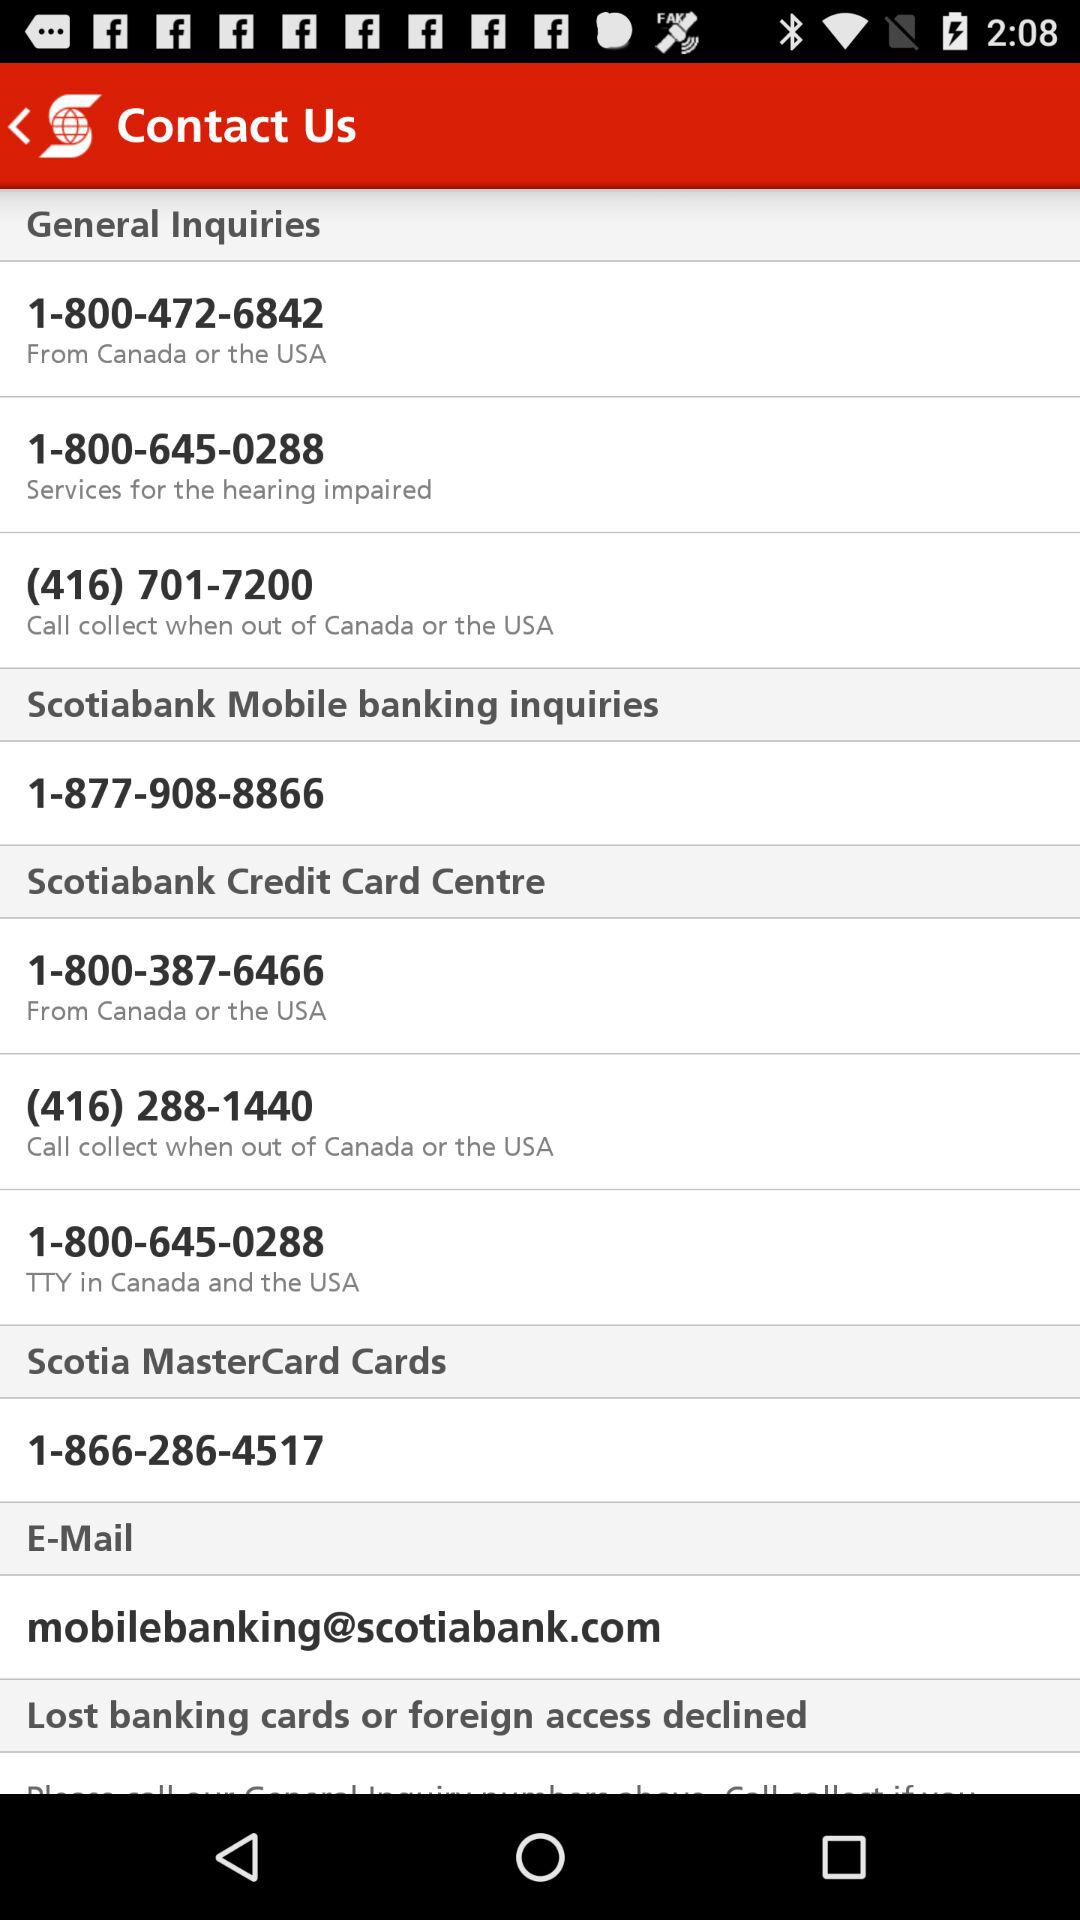What's the phone number for mobile banking inquiries? The phone number for mobile banking inquiries is 1-877-908-8866. 